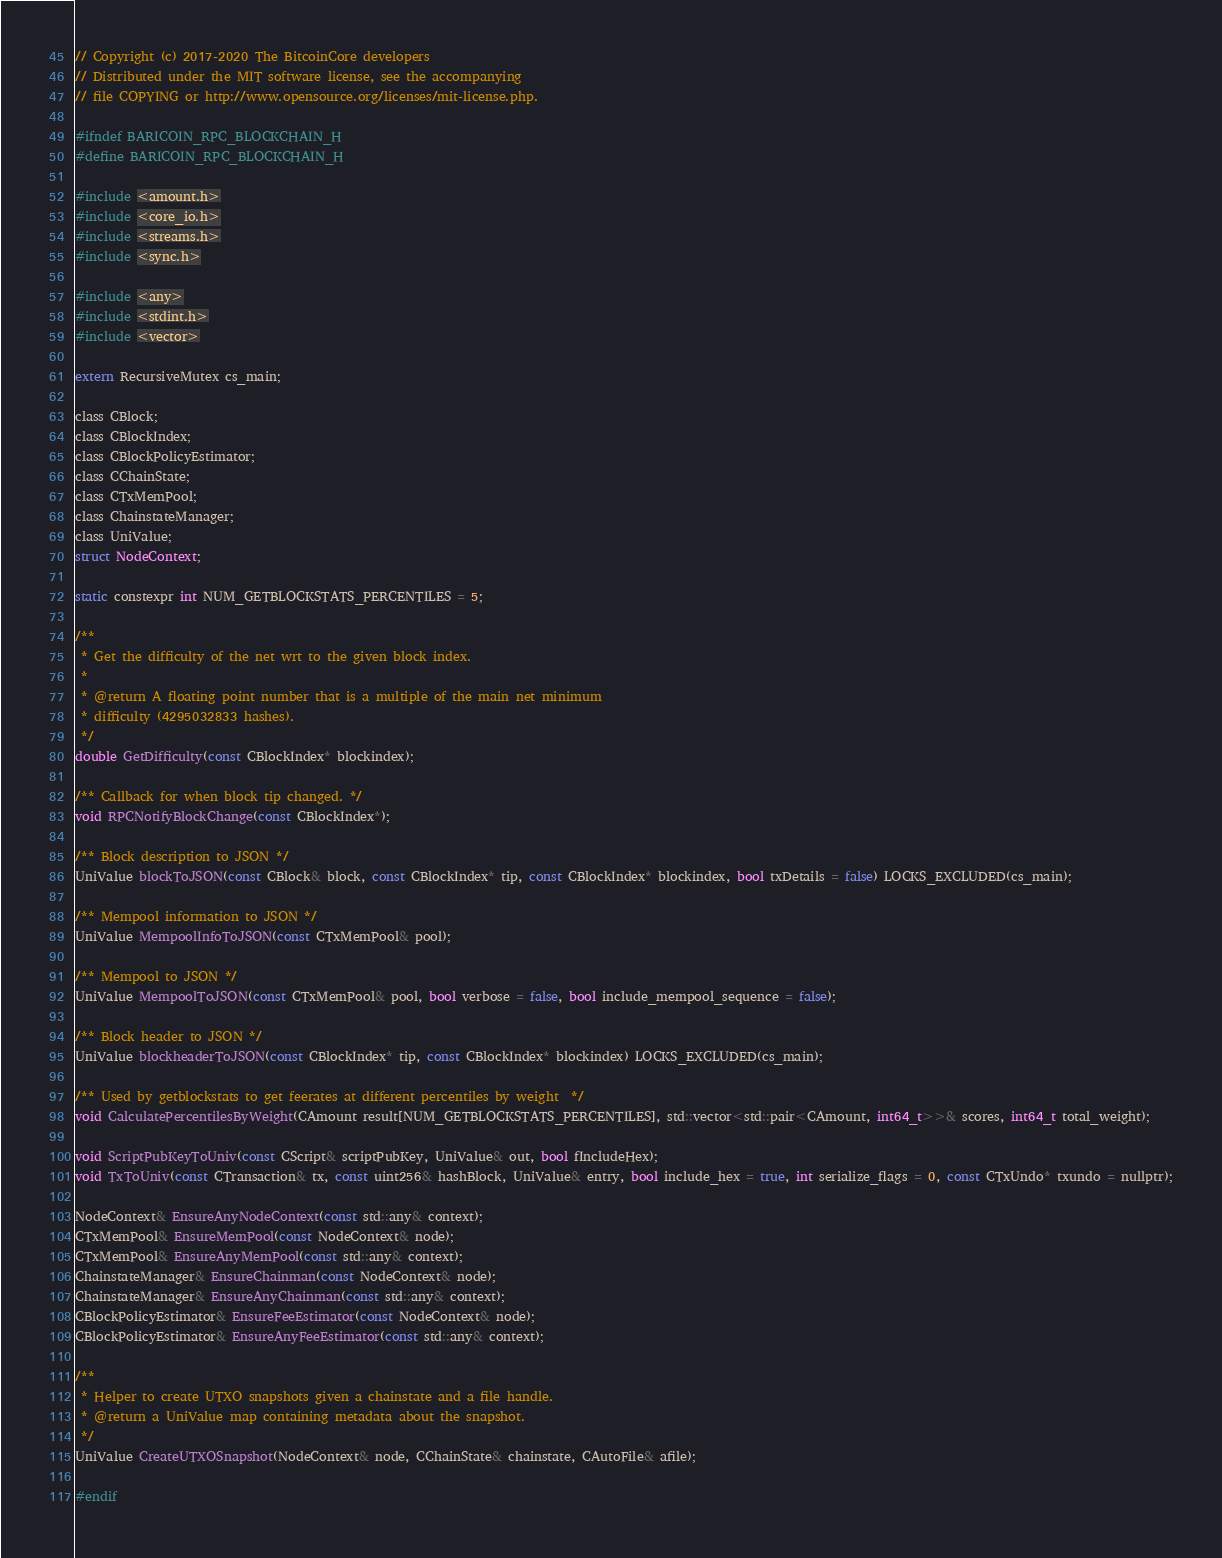<code> <loc_0><loc_0><loc_500><loc_500><_C_>// Copyright (c) 2017-2020 The BitcoinCore developers
// Distributed under the MIT software license, see the accompanying
// file COPYING or http://www.opensource.org/licenses/mit-license.php.

#ifndef BARICOIN_RPC_BLOCKCHAIN_H
#define BARICOIN_RPC_BLOCKCHAIN_H

#include <amount.h>
#include <core_io.h>
#include <streams.h>
#include <sync.h>

#include <any>
#include <stdint.h>
#include <vector>

extern RecursiveMutex cs_main;

class CBlock;
class CBlockIndex;
class CBlockPolicyEstimator;
class CChainState;
class CTxMemPool;
class ChainstateManager;
class UniValue;
struct NodeContext;

static constexpr int NUM_GETBLOCKSTATS_PERCENTILES = 5;

/**
 * Get the difficulty of the net wrt to the given block index.
 *
 * @return A floating point number that is a multiple of the main net minimum
 * difficulty (4295032833 hashes).
 */
double GetDifficulty(const CBlockIndex* blockindex);

/** Callback for when block tip changed. */
void RPCNotifyBlockChange(const CBlockIndex*);

/** Block description to JSON */
UniValue blockToJSON(const CBlock& block, const CBlockIndex* tip, const CBlockIndex* blockindex, bool txDetails = false) LOCKS_EXCLUDED(cs_main);

/** Mempool information to JSON */
UniValue MempoolInfoToJSON(const CTxMemPool& pool);

/** Mempool to JSON */
UniValue MempoolToJSON(const CTxMemPool& pool, bool verbose = false, bool include_mempool_sequence = false);

/** Block header to JSON */
UniValue blockheaderToJSON(const CBlockIndex* tip, const CBlockIndex* blockindex) LOCKS_EXCLUDED(cs_main);

/** Used by getblockstats to get feerates at different percentiles by weight  */
void CalculatePercentilesByWeight(CAmount result[NUM_GETBLOCKSTATS_PERCENTILES], std::vector<std::pair<CAmount, int64_t>>& scores, int64_t total_weight);

void ScriptPubKeyToUniv(const CScript& scriptPubKey, UniValue& out, bool fIncludeHex);
void TxToUniv(const CTransaction& tx, const uint256& hashBlock, UniValue& entry, bool include_hex = true, int serialize_flags = 0, const CTxUndo* txundo = nullptr);

NodeContext& EnsureAnyNodeContext(const std::any& context);
CTxMemPool& EnsureMemPool(const NodeContext& node);
CTxMemPool& EnsureAnyMemPool(const std::any& context);
ChainstateManager& EnsureChainman(const NodeContext& node);
ChainstateManager& EnsureAnyChainman(const std::any& context);
CBlockPolicyEstimator& EnsureFeeEstimator(const NodeContext& node);
CBlockPolicyEstimator& EnsureAnyFeeEstimator(const std::any& context);

/**
 * Helper to create UTXO snapshots given a chainstate and a file handle.
 * @return a UniValue map containing metadata about the snapshot.
 */
UniValue CreateUTXOSnapshot(NodeContext& node, CChainState& chainstate, CAutoFile& afile);

#endif
</code> 